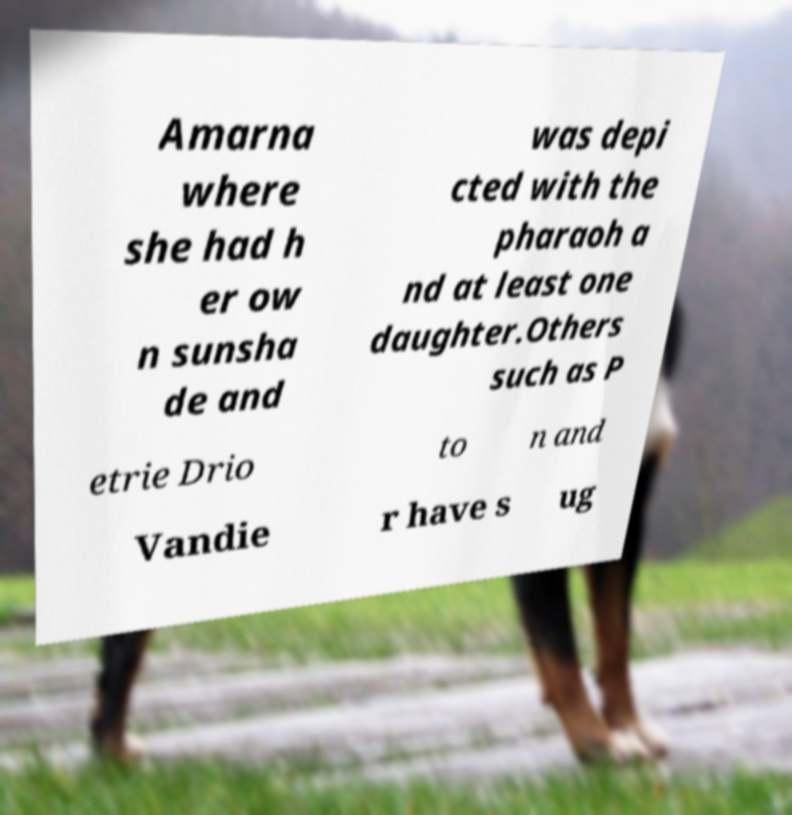There's text embedded in this image that I need extracted. Can you transcribe it verbatim? Amarna where she had h er ow n sunsha de and was depi cted with the pharaoh a nd at least one daughter.Others such as P etrie Drio to n and Vandie r have s ug 